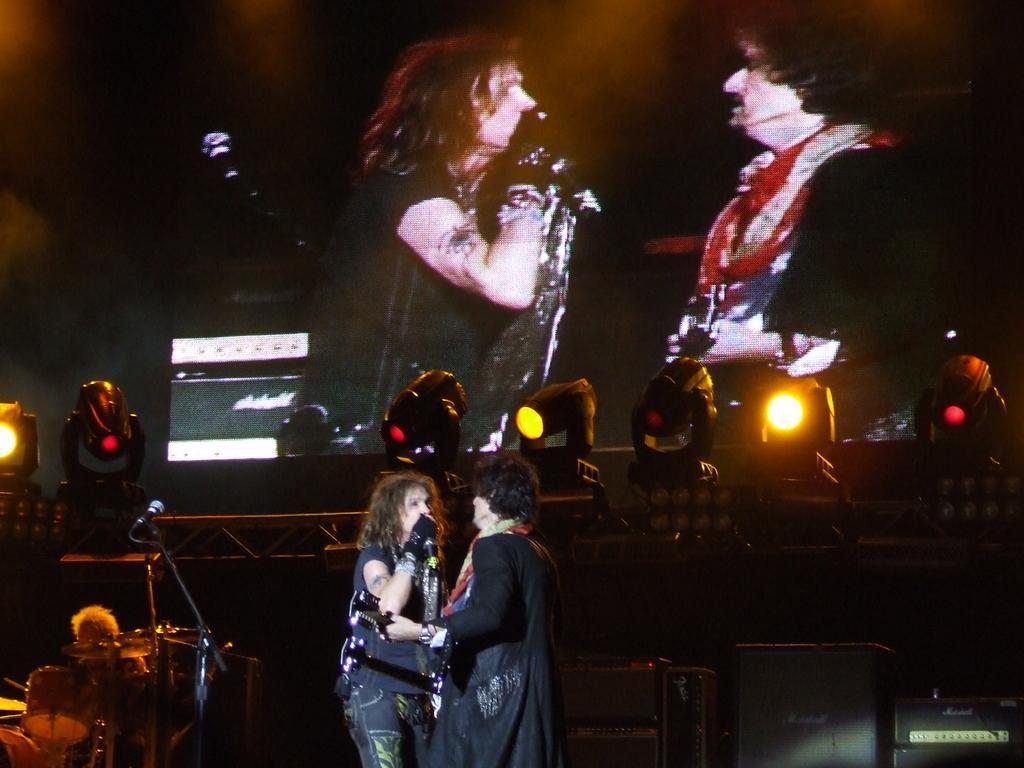Describe this image in one or two sentences. These are focusing lights. On top there is a screen. These 2 women are standing. This woman is singing in a mic. These are musical instruments. 